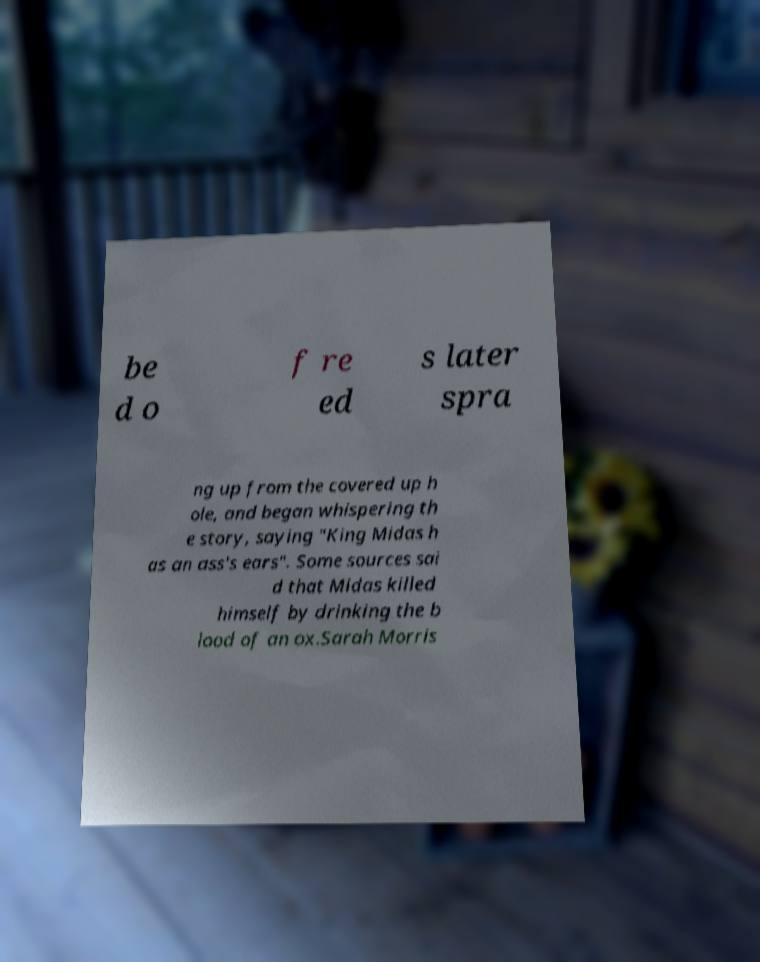For documentation purposes, I need the text within this image transcribed. Could you provide that? be d o f re ed s later spra ng up from the covered up h ole, and began whispering th e story, saying "King Midas h as an ass's ears". Some sources sai d that Midas killed himself by drinking the b lood of an ox.Sarah Morris 